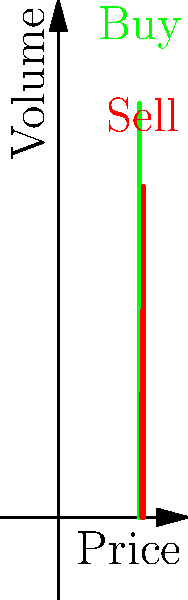Given the vector-based order book representation shown in the graph, what is the optimal trade execution strategy to buy 400 shares while minimizing market impact? Assume you can execute partial orders and the market depth is limited to what's shown. To optimize the trade execution strategy while minimizing market impact, we need to analyze the order book representation carefully:

1. The buy (green) and sell (red) orders are represented as vectors on the price-volume plane.

2. We need to buy 400 shares, so we'll start from the lowest ask price and work our way up.

3. Order execution:
   a) At price 101: We can buy 150 shares (full volume available)
   b) At price 102: We can buy 250 shares (full volume available)
   
   Total shares bought so far: 150 + 250 = 400

4. We've reached our target of 400 shares without needing to go to the next price level.

5. This strategy minimizes market impact because:
   a) We're using all available liquidity at the best prices.
   b) We're not pushing the price up unnecessarily by executing at higher price levels.

6. The weighted average execution price (VWAP) for this strategy is:
   $$ VWAP = \frac{(101 * 150) + (102 * 250)}{400} = 101.625 $$

This strategy ensures we buy the required shares at the lowest possible average price while minimizing our impact on the market.
Answer: Buy 150 shares at $101 and 250 shares at $102. 